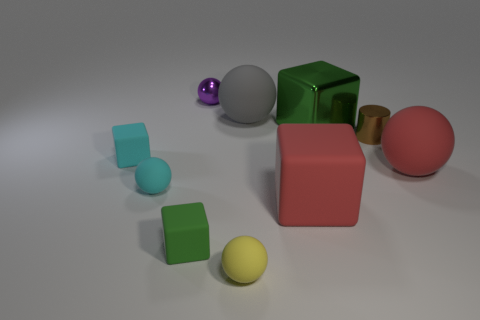How many other small metal objects have the same shape as the purple object?
Provide a short and direct response. 0. What is the size of the green block that is to the right of the tiny purple ball on the left side of the tiny metal cylinder?
Provide a succinct answer. Large. How many brown objects are either rubber blocks or shiny cylinders?
Provide a succinct answer. 1. Are there fewer big spheres behind the tiny brown metallic cylinder than big matte cubes that are on the left side of the gray thing?
Offer a very short reply. No. There is a cyan cube; is its size the same as the red rubber block that is to the left of the tiny cylinder?
Provide a short and direct response. No. How many balls are the same size as the brown object?
Offer a terse response. 3. How many big things are yellow rubber cubes or purple balls?
Your answer should be very brief. 0. Are there any small blocks?
Your response must be concise. Yes. Are there more small things on the right side of the small yellow sphere than green cubes that are on the left side of the large red cube?
Provide a succinct answer. No. What is the color of the large rubber ball behind the green thing that is behind the small green rubber cube?
Ensure brevity in your answer.  Gray. 